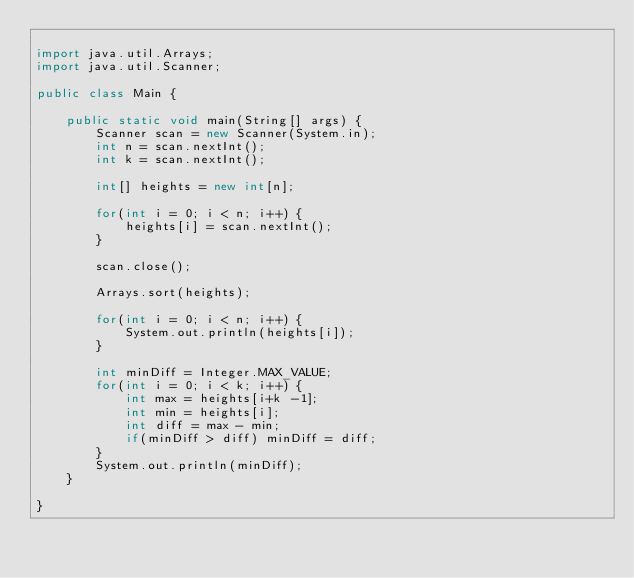Convert code to text. <code><loc_0><loc_0><loc_500><loc_500><_Java_>
import java.util.Arrays;
import java.util.Scanner;

public class Main {

	public static void main(String[] args) {
		Scanner scan = new Scanner(System.in);
		int n = scan.nextInt();
		int k = scan.nextInt();

		int[] heights = new int[n];

		for(int i = 0; i < n; i++) {
			heights[i] = scan.nextInt();
		}

		scan.close();

		Arrays.sort(heights);

		for(int i = 0; i < n; i++) {
			System.out.println(heights[i]);
		}

		int minDiff = Integer.MAX_VALUE;
		for(int i = 0; i < k; i++) {
			int max = heights[i+k -1];
			int min = heights[i];
			int diff = max - min;
			if(minDiff > diff) minDiff = diff;
		}
		System.out.println(minDiff);
	}

}</code> 